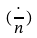<formula> <loc_0><loc_0><loc_500><loc_500>( \frac { \cdot } { n } )</formula> 